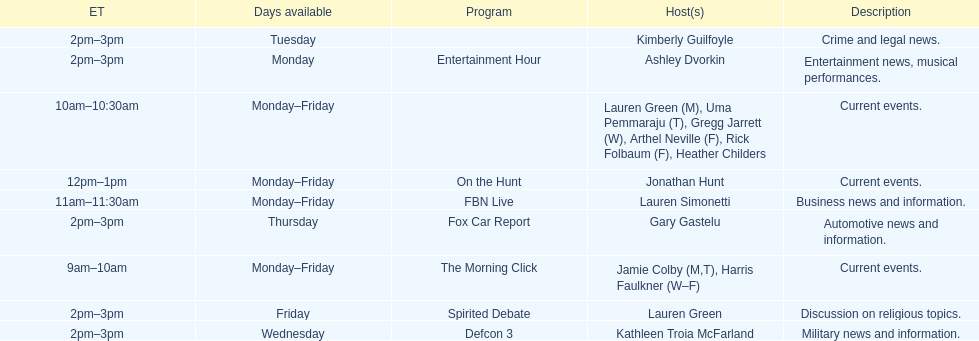How many days is fbn live available each week? 5. 